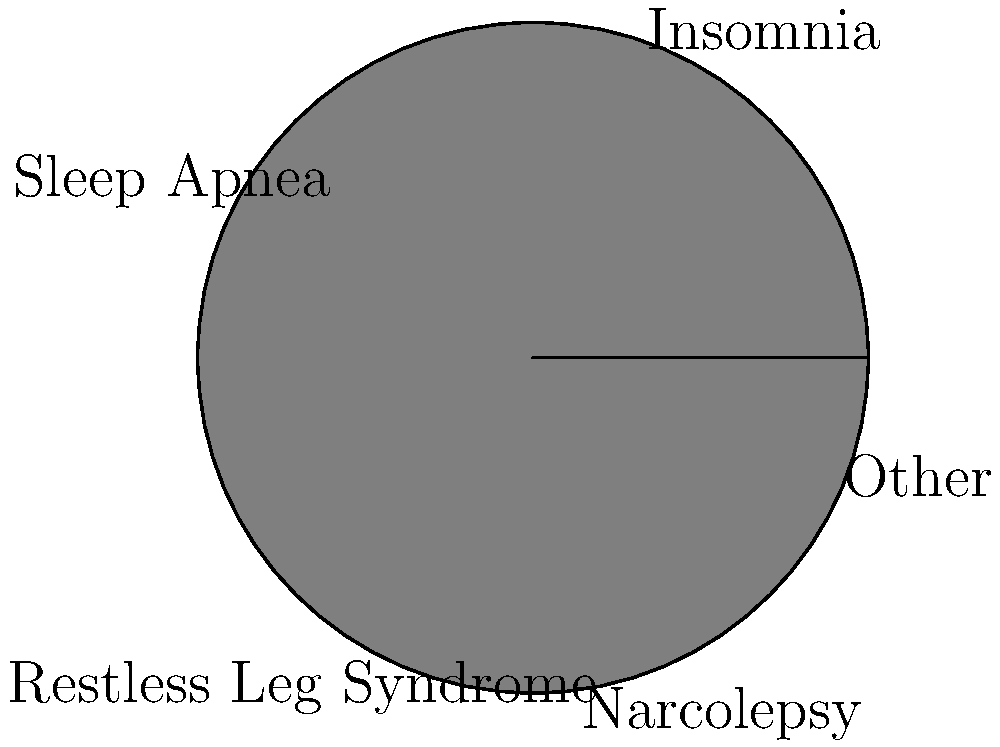A pie chart represents the distribution of sleep disorders among patients with autoimmune diseases. The chart has a radius of 10 cm. If the sector representing insomnia covers 30% of the total area, what is the area of this sector in square centimeters? Round your answer to two decimal places. To solve this problem, we need to follow these steps:

1. Calculate the total area of the circular pie chart:
   $A_{total} = \pi r^2 = \pi (10 \text{ cm})^2 = 100\pi \text{ cm}^2$

2. Calculate the area of the insomnia sector:
   The insomnia sector represents 30% of the total area.
   $A_{insomnia} = 30\% \text{ of } A_{total} = 0.30 \times 100\pi \text{ cm}^2 = 30\pi \text{ cm}^2$

3. Calculate the exact value:
   $A_{insomnia} = 30\pi \approx 94.2477796076938 \text{ cm}^2$

4. Round the result to two decimal places:
   $A_{insomnia} \approx 94.25 \text{ cm}^2$

Therefore, the area of the sector representing insomnia is approximately 94.25 square centimeters.
Answer: $94.25 \text{ cm}^2$ 